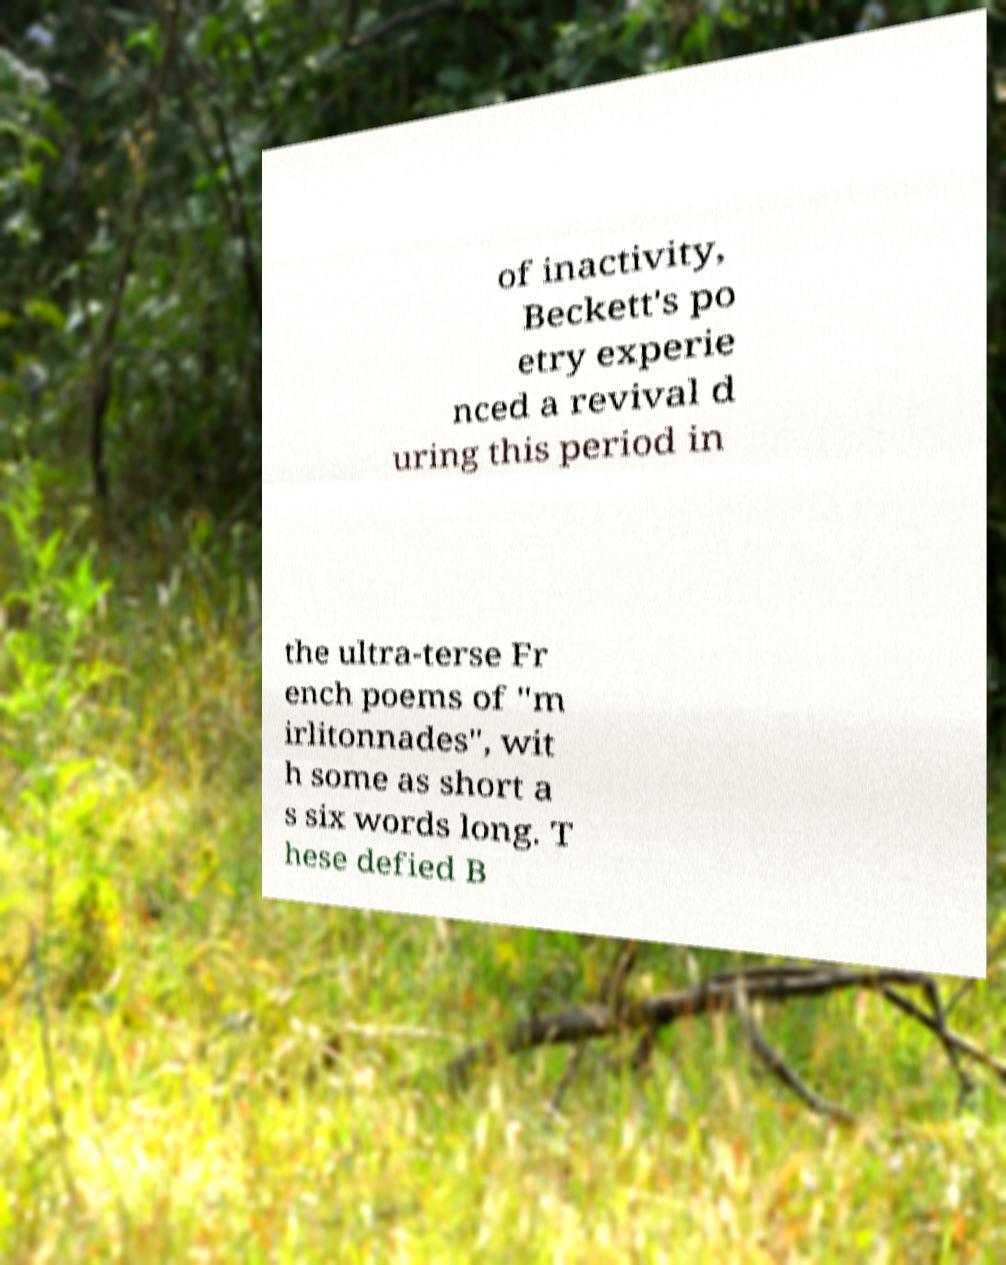Please identify and transcribe the text found in this image. of inactivity, Beckett's po etry experie nced a revival d uring this period in the ultra-terse Fr ench poems of "m irlitonnades", wit h some as short a s six words long. T hese defied B 